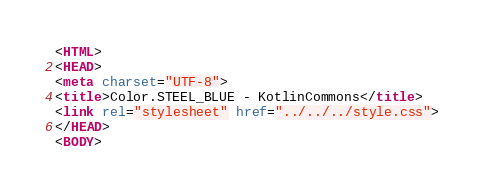Convert code to text. <code><loc_0><loc_0><loc_500><loc_500><_HTML_><HTML>
<HEAD>
<meta charset="UTF-8">
<title>Color.STEEL_BLUE - KotlinCommons</title>
<link rel="stylesheet" href="../../../style.css">
</HEAD>
<BODY></code> 